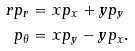<formula> <loc_0><loc_0><loc_500><loc_500>r p _ { r } & = x p _ { x } + y p _ { y } \\ p _ { \theta } & = x p _ { y } - y p _ { x } .</formula> 